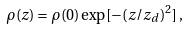<formula> <loc_0><loc_0><loc_500><loc_500>\rho ( z ) = \rho ( 0 ) \exp [ - ( z / z _ { d } ) ^ { 2 } ] \, ,</formula> 